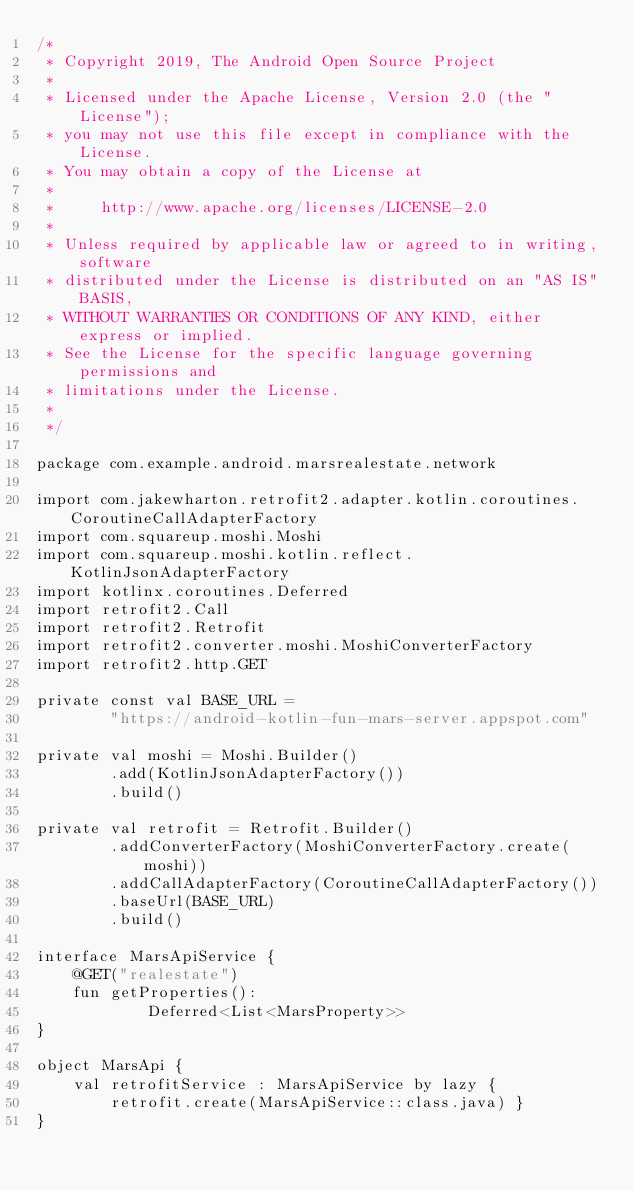Convert code to text. <code><loc_0><loc_0><loc_500><loc_500><_Kotlin_>/*
 * Copyright 2019, The Android Open Source Project
 *
 * Licensed under the Apache License, Version 2.0 (the "License");
 * you may not use this file except in compliance with the License.
 * You may obtain a copy of the License at
 *
 *     http://www.apache.org/licenses/LICENSE-2.0
 *
 * Unless required by applicable law or agreed to in writing, software
 * distributed under the License is distributed on an "AS IS" BASIS,
 * WITHOUT WARRANTIES OR CONDITIONS OF ANY KIND, either express or implied.
 * See the License for the specific language governing permissions and
 * limitations under the License.
 *
 */

package com.example.android.marsrealestate.network

import com.jakewharton.retrofit2.adapter.kotlin.coroutines.CoroutineCallAdapterFactory
import com.squareup.moshi.Moshi
import com.squareup.moshi.kotlin.reflect.KotlinJsonAdapterFactory
import kotlinx.coroutines.Deferred
import retrofit2.Call
import retrofit2.Retrofit
import retrofit2.converter.moshi.MoshiConverterFactory
import retrofit2.http.GET

private const val BASE_URL =
        "https://android-kotlin-fun-mars-server.appspot.com"

private val moshi = Moshi.Builder()
        .add(KotlinJsonAdapterFactory())
        .build()

private val retrofit = Retrofit.Builder()
        .addConverterFactory(MoshiConverterFactory.create(moshi))
        .addCallAdapterFactory(CoroutineCallAdapterFactory())
        .baseUrl(BASE_URL)
        .build()

interface MarsApiService {
    @GET("realestate")
    fun getProperties():
            Deferred<List<MarsProperty>>
}

object MarsApi {
    val retrofitService : MarsApiService by lazy {
        retrofit.create(MarsApiService::class.java) }
}</code> 